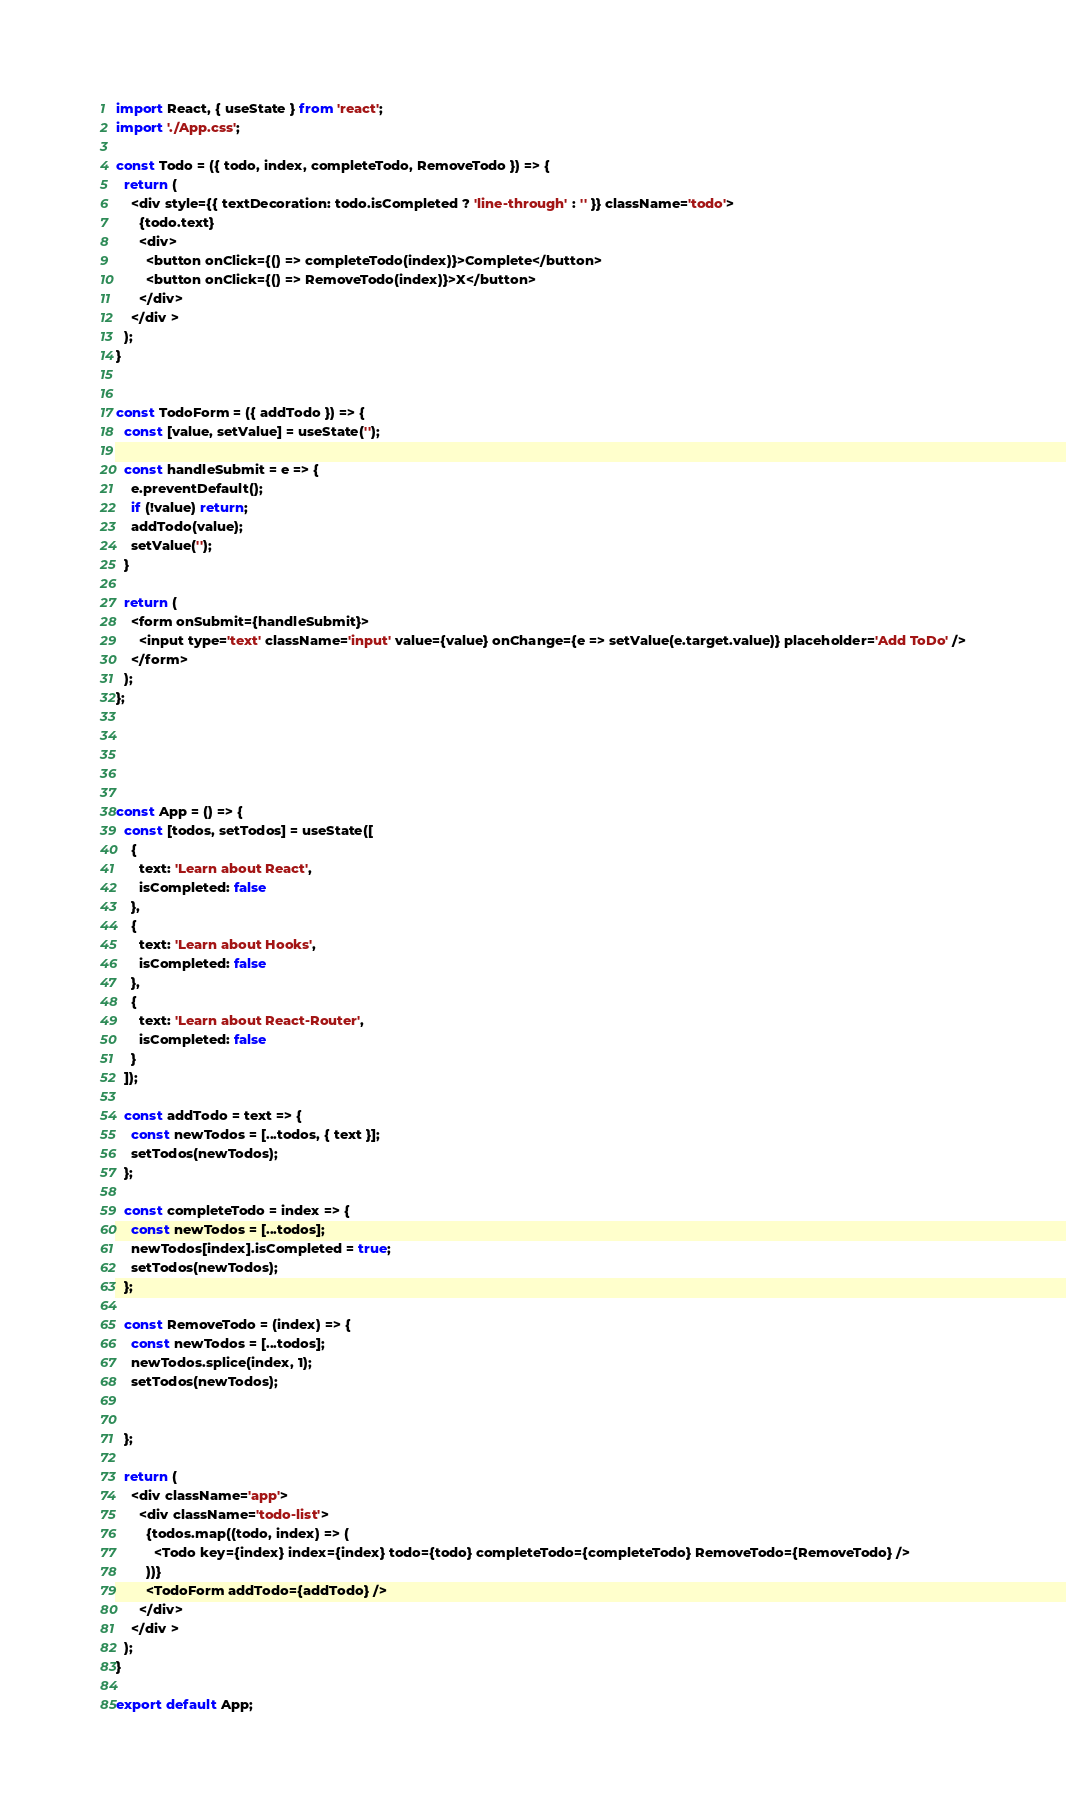<code> <loc_0><loc_0><loc_500><loc_500><_JavaScript_>
import React, { useState } from 'react';
import './App.css';

const Todo = ({ todo, index, completeTodo, RemoveTodo }) => {
  return (
    <div style={{ textDecoration: todo.isCompleted ? 'line-through' : '' }} className='todo'>
      {todo.text}
      <div>
        <button onClick={() => completeTodo(index)}>Complete</button>
        <button onClick={() => RemoveTodo(index)}>X</button>
      </div>
    </div >
  );
}


const TodoForm = ({ addTodo }) => {
  const [value, setValue] = useState('');

  const handleSubmit = e => {
    e.preventDefault();
    if (!value) return;
    addTodo(value);
    setValue('');
  }

  return (
    <form onSubmit={handleSubmit}>
      <input type='text' className='input' value={value} onChange={e => setValue(e.target.value)} placeholder='Add ToDo' />
    </form>
  );
};





const App = () => {
  const [todos, setTodos] = useState([
    {
      text: 'Learn about React',
      isCompleted: false
    },
    {
      text: 'Learn about Hooks',
      isCompleted: false
    },
    {
      text: 'Learn about React-Router',
      isCompleted: false
    }
  ]);

  const addTodo = text => {
    const newTodos = [...todos, { text }];
    setTodos(newTodos);
  };

  const completeTodo = index => {
    const newTodos = [...todos];
    newTodos[index].isCompleted = true;
    setTodos(newTodos);
  };

  const RemoveTodo = (index) => {
    const newTodos = [...todos];
    newTodos.splice(index, 1);
    setTodos(newTodos);


  };

  return (
    <div className='app'>
      <div className='todo-list'>
        {todos.map((todo, index) => (
          <Todo key={index} index={index} todo={todo} completeTodo={completeTodo} RemoveTodo={RemoveTodo} />
        ))}
        <TodoForm addTodo={addTodo} />
      </div>
    </div >
  );
}

export default App;</code> 